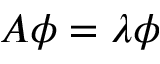Convert formula to latex. <formula><loc_0><loc_0><loc_500><loc_500>A \phi = \lambda \phi</formula> 